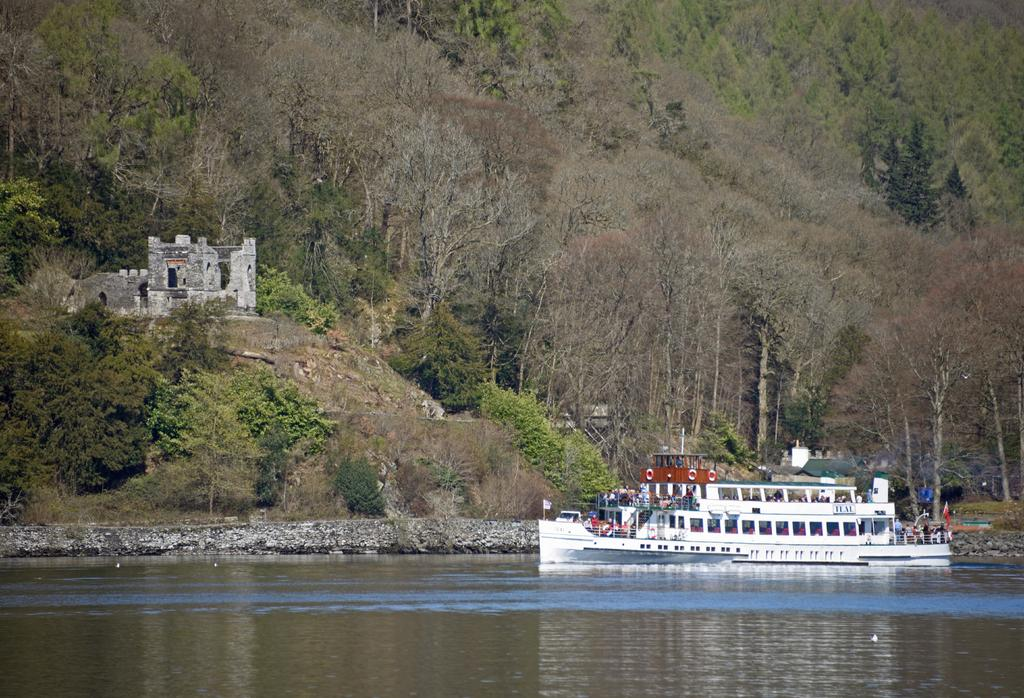What is the main subject of the image? There are people on a boat in the image. What color is the boat? The boat is white in color. Where is the boat located? The boat is on the water. What can be seen in the background of the image? There are trees, plants, and other objects visible in the background of the image. What design is featured on the boat's sail? There is no sail visible in the image, so it is not possible to determine the design on it. 